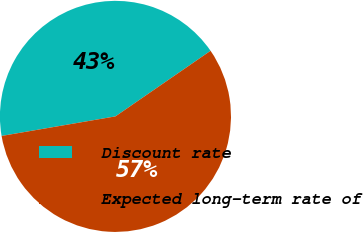Convert chart. <chart><loc_0><loc_0><loc_500><loc_500><pie_chart><fcel>Discount rate<fcel>Expected long-term rate of<nl><fcel>43.1%<fcel>56.9%<nl></chart> 